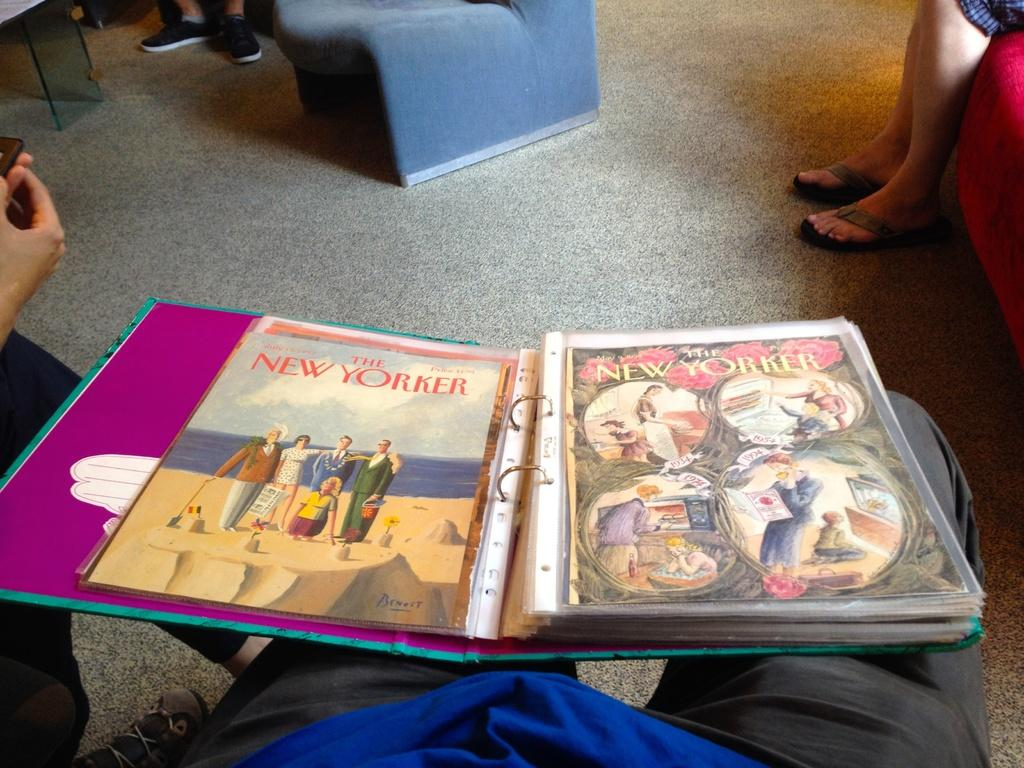<image>
Provide a brief description of the given image. A binder has different versions of The New Yorker magazine in protective plastic coverings 